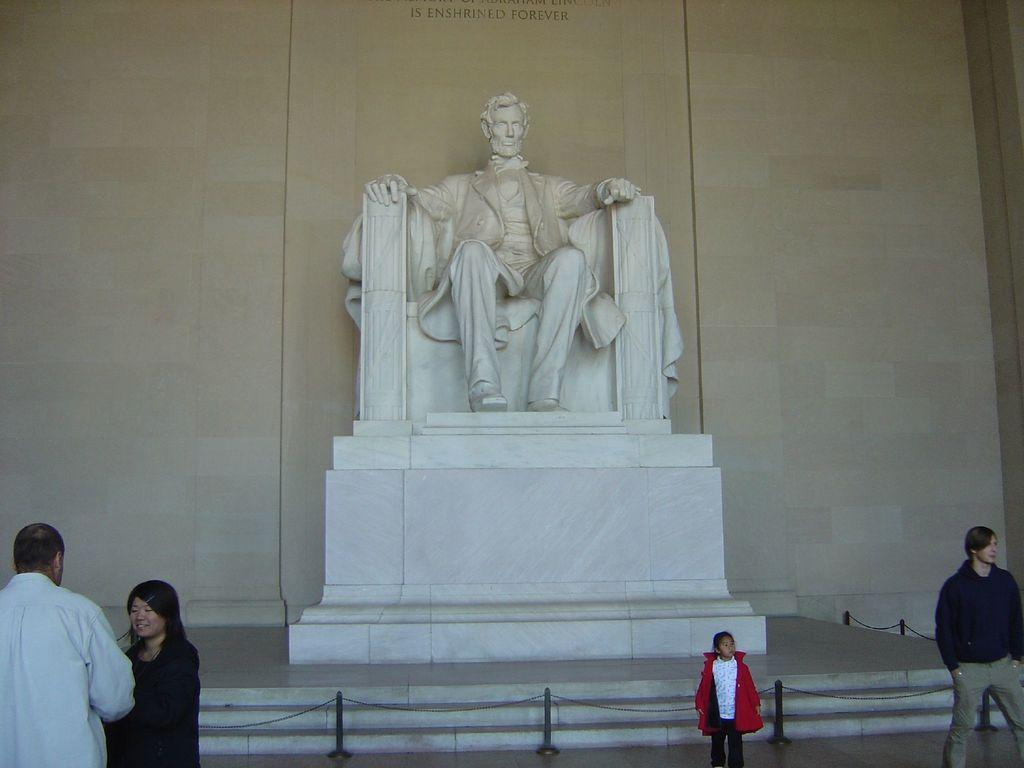What is the main subject of the image? The main subject of the image is a sculpture of a person sitting on a chair. Can you describe the people in the image? There are people standing beside the stairs in the image. How many trucks are parked near the sculpture in the image? There are no trucks present in the image. What type of giants can be seen interacting with the sculpture in the image? There are no giants present in the image. 